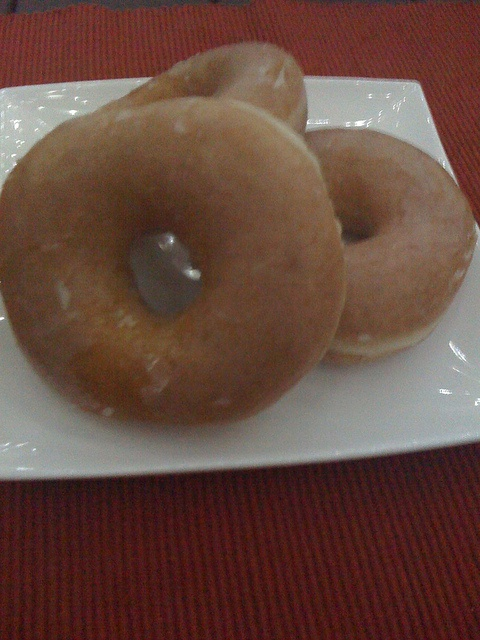Describe the objects in this image and their specific colors. I can see dining table in maroon, darkgray, gray, and black tones, donut in black, maroon, and gray tones, donut in black, gray, brown, and maroon tones, and donut in black, gray, and brown tones in this image. 